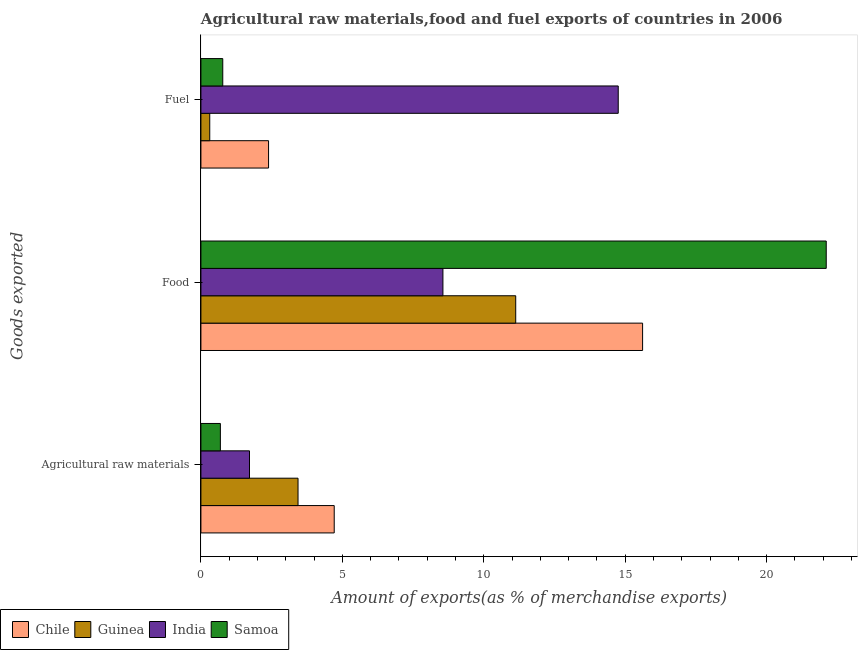How many different coloured bars are there?
Provide a succinct answer. 4. How many groups of bars are there?
Offer a terse response. 3. Are the number of bars on each tick of the Y-axis equal?
Provide a succinct answer. Yes. How many bars are there on the 2nd tick from the top?
Your answer should be very brief. 4. What is the label of the 1st group of bars from the top?
Offer a terse response. Fuel. What is the percentage of raw materials exports in India?
Make the answer very short. 1.72. Across all countries, what is the maximum percentage of food exports?
Provide a short and direct response. 22.11. Across all countries, what is the minimum percentage of fuel exports?
Offer a very short reply. 0.31. In which country was the percentage of food exports maximum?
Provide a succinct answer. Samoa. In which country was the percentage of fuel exports minimum?
Keep it short and to the point. Guinea. What is the total percentage of fuel exports in the graph?
Make the answer very short. 18.23. What is the difference between the percentage of fuel exports in Guinea and that in Samoa?
Provide a short and direct response. -0.46. What is the difference between the percentage of food exports in Samoa and the percentage of raw materials exports in Chile?
Provide a short and direct response. 17.39. What is the average percentage of raw materials exports per country?
Give a very brief answer. 2.64. What is the difference between the percentage of fuel exports and percentage of food exports in India?
Provide a succinct answer. 6.2. In how many countries, is the percentage of fuel exports greater than 17 %?
Offer a terse response. 0. What is the ratio of the percentage of fuel exports in Guinea to that in Samoa?
Make the answer very short. 0.4. Is the percentage of food exports in Chile less than that in Samoa?
Provide a short and direct response. Yes. Is the difference between the percentage of food exports in Guinea and India greater than the difference between the percentage of fuel exports in Guinea and India?
Your answer should be compact. Yes. What is the difference between the highest and the second highest percentage of food exports?
Provide a succinct answer. 6.49. What is the difference between the highest and the lowest percentage of fuel exports?
Provide a short and direct response. 14.44. In how many countries, is the percentage of raw materials exports greater than the average percentage of raw materials exports taken over all countries?
Offer a very short reply. 2. Is the sum of the percentage of raw materials exports in India and Guinea greater than the maximum percentage of food exports across all countries?
Keep it short and to the point. No. What does the 1st bar from the top in Food represents?
Your answer should be very brief. Samoa. What does the 3rd bar from the bottom in Agricultural raw materials represents?
Keep it short and to the point. India. Is it the case that in every country, the sum of the percentage of raw materials exports and percentage of food exports is greater than the percentage of fuel exports?
Your answer should be very brief. No. How many countries are there in the graph?
Ensure brevity in your answer.  4. What is the difference between two consecutive major ticks on the X-axis?
Offer a terse response. 5. Are the values on the major ticks of X-axis written in scientific E-notation?
Provide a succinct answer. No. Where does the legend appear in the graph?
Offer a very short reply. Bottom left. What is the title of the graph?
Your answer should be compact. Agricultural raw materials,food and fuel exports of countries in 2006. What is the label or title of the X-axis?
Ensure brevity in your answer.  Amount of exports(as % of merchandise exports). What is the label or title of the Y-axis?
Provide a succinct answer. Goods exported. What is the Amount of exports(as % of merchandise exports) of Chile in Agricultural raw materials?
Your answer should be very brief. 4.71. What is the Amount of exports(as % of merchandise exports) in Guinea in Agricultural raw materials?
Provide a short and direct response. 3.43. What is the Amount of exports(as % of merchandise exports) in India in Agricultural raw materials?
Provide a succinct answer. 1.72. What is the Amount of exports(as % of merchandise exports) of Samoa in Agricultural raw materials?
Offer a very short reply. 0.69. What is the Amount of exports(as % of merchandise exports) in Chile in Food?
Your response must be concise. 15.62. What is the Amount of exports(as % of merchandise exports) of Guinea in Food?
Provide a succinct answer. 11.13. What is the Amount of exports(as % of merchandise exports) in India in Food?
Keep it short and to the point. 8.56. What is the Amount of exports(as % of merchandise exports) of Samoa in Food?
Your answer should be very brief. 22.11. What is the Amount of exports(as % of merchandise exports) in Chile in Fuel?
Ensure brevity in your answer.  2.39. What is the Amount of exports(as % of merchandise exports) in Guinea in Fuel?
Provide a short and direct response. 0.31. What is the Amount of exports(as % of merchandise exports) in India in Fuel?
Your response must be concise. 14.75. What is the Amount of exports(as % of merchandise exports) in Samoa in Fuel?
Your answer should be very brief. 0.77. Across all Goods exported, what is the maximum Amount of exports(as % of merchandise exports) in Chile?
Provide a short and direct response. 15.62. Across all Goods exported, what is the maximum Amount of exports(as % of merchandise exports) of Guinea?
Offer a very short reply. 11.13. Across all Goods exported, what is the maximum Amount of exports(as % of merchandise exports) of India?
Offer a terse response. 14.75. Across all Goods exported, what is the maximum Amount of exports(as % of merchandise exports) in Samoa?
Keep it short and to the point. 22.11. Across all Goods exported, what is the minimum Amount of exports(as % of merchandise exports) of Chile?
Keep it short and to the point. 2.39. Across all Goods exported, what is the minimum Amount of exports(as % of merchandise exports) of Guinea?
Offer a very short reply. 0.31. Across all Goods exported, what is the minimum Amount of exports(as % of merchandise exports) in India?
Your answer should be very brief. 1.72. Across all Goods exported, what is the minimum Amount of exports(as % of merchandise exports) of Samoa?
Give a very brief answer. 0.69. What is the total Amount of exports(as % of merchandise exports) of Chile in the graph?
Your response must be concise. 22.72. What is the total Amount of exports(as % of merchandise exports) of Guinea in the graph?
Your answer should be very brief. 14.88. What is the total Amount of exports(as % of merchandise exports) of India in the graph?
Your answer should be compact. 25.03. What is the total Amount of exports(as % of merchandise exports) of Samoa in the graph?
Your answer should be compact. 23.57. What is the difference between the Amount of exports(as % of merchandise exports) of Chile in Agricultural raw materials and that in Food?
Make the answer very short. -10.9. What is the difference between the Amount of exports(as % of merchandise exports) of Guinea in Agricultural raw materials and that in Food?
Your response must be concise. -7.7. What is the difference between the Amount of exports(as % of merchandise exports) in India in Agricultural raw materials and that in Food?
Give a very brief answer. -6.84. What is the difference between the Amount of exports(as % of merchandise exports) of Samoa in Agricultural raw materials and that in Food?
Ensure brevity in your answer.  -21.42. What is the difference between the Amount of exports(as % of merchandise exports) of Chile in Agricultural raw materials and that in Fuel?
Your answer should be compact. 2.32. What is the difference between the Amount of exports(as % of merchandise exports) of Guinea in Agricultural raw materials and that in Fuel?
Your answer should be compact. 3.12. What is the difference between the Amount of exports(as % of merchandise exports) of India in Agricultural raw materials and that in Fuel?
Keep it short and to the point. -13.04. What is the difference between the Amount of exports(as % of merchandise exports) of Samoa in Agricultural raw materials and that in Fuel?
Provide a short and direct response. -0.08. What is the difference between the Amount of exports(as % of merchandise exports) in Chile in Food and that in Fuel?
Your answer should be compact. 13.22. What is the difference between the Amount of exports(as % of merchandise exports) of Guinea in Food and that in Fuel?
Your answer should be very brief. 10.82. What is the difference between the Amount of exports(as % of merchandise exports) in India in Food and that in Fuel?
Provide a succinct answer. -6.2. What is the difference between the Amount of exports(as % of merchandise exports) of Samoa in Food and that in Fuel?
Provide a short and direct response. 21.34. What is the difference between the Amount of exports(as % of merchandise exports) in Chile in Agricultural raw materials and the Amount of exports(as % of merchandise exports) in Guinea in Food?
Provide a succinct answer. -6.42. What is the difference between the Amount of exports(as % of merchandise exports) in Chile in Agricultural raw materials and the Amount of exports(as % of merchandise exports) in India in Food?
Ensure brevity in your answer.  -3.84. What is the difference between the Amount of exports(as % of merchandise exports) in Chile in Agricultural raw materials and the Amount of exports(as % of merchandise exports) in Samoa in Food?
Your answer should be compact. -17.39. What is the difference between the Amount of exports(as % of merchandise exports) in Guinea in Agricultural raw materials and the Amount of exports(as % of merchandise exports) in India in Food?
Your response must be concise. -5.12. What is the difference between the Amount of exports(as % of merchandise exports) in Guinea in Agricultural raw materials and the Amount of exports(as % of merchandise exports) in Samoa in Food?
Make the answer very short. -18.67. What is the difference between the Amount of exports(as % of merchandise exports) in India in Agricultural raw materials and the Amount of exports(as % of merchandise exports) in Samoa in Food?
Make the answer very short. -20.39. What is the difference between the Amount of exports(as % of merchandise exports) in Chile in Agricultural raw materials and the Amount of exports(as % of merchandise exports) in Guinea in Fuel?
Provide a succinct answer. 4.4. What is the difference between the Amount of exports(as % of merchandise exports) in Chile in Agricultural raw materials and the Amount of exports(as % of merchandise exports) in India in Fuel?
Keep it short and to the point. -10.04. What is the difference between the Amount of exports(as % of merchandise exports) in Chile in Agricultural raw materials and the Amount of exports(as % of merchandise exports) in Samoa in Fuel?
Make the answer very short. 3.94. What is the difference between the Amount of exports(as % of merchandise exports) in Guinea in Agricultural raw materials and the Amount of exports(as % of merchandise exports) in India in Fuel?
Your answer should be compact. -11.32. What is the difference between the Amount of exports(as % of merchandise exports) in Guinea in Agricultural raw materials and the Amount of exports(as % of merchandise exports) in Samoa in Fuel?
Provide a succinct answer. 2.66. What is the difference between the Amount of exports(as % of merchandise exports) of India in Agricultural raw materials and the Amount of exports(as % of merchandise exports) of Samoa in Fuel?
Ensure brevity in your answer.  0.95. What is the difference between the Amount of exports(as % of merchandise exports) in Chile in Food and the Amount of exports(as % of merchandise exports) in Guinea in Fuel?
Your answer should be very brief. 15.3. What is the difference between the Amount of exports(as % of merchandise exports) of Chile in Food and the Amount of exports(as % of merchandise exports) of India in Fuel?
Your answer should be very brief. 0.86. What is the difference between the Amount of exports(as % of merchandise exports) of Chile in Food and the Amount of exports(as % of merchandise exports) of Samoa in Fuel?
Offer a terse response. 14.84. What is the difference between the Amount of exports(as % of merchandise exports) in Guinea in Food and the Amount of exports(as % of merchandise exports) in India in Fuel?
Provide a succinct answer. -3.62. What is the difference between the Amount of exports(as % of merchandise exports) in Guinea in Food and the Amount of exports(as % of merchandise exports) in Samoa in Fuel?
Provide a short and direct response. 10.36. What is the difference between the Amount of exports(as % of merchandise exports) of India in Food and the Amount of exports(as % of merchandise exports) of Samoa in Fuel?
Provide a succinct answer. 7.78. What is the average Amount of exports(as % of merchandise exports) in Chile per Goods exported?
Keep it short and to the point. 7.57. What is the average Amount of exports(as % of merchandise exports) in Guinea per Goods exported?
Your response must be concise. 4.96. What is the average Amount of exports(as % of merchandise exports) of India per Goods exported?
Give a very brief answer. 8.34. What is the average Amount of exports(as % of merchandise exports) of Samoa per Goods exported?
Give a very brief answer. 7.86. What is the difference between the Amount of exports(as % of merchandise exports) of Chile and Amount of exports(as % of merchandise exports) of Guinea in Agricultural raw materials?
Your answer should be very brief. 1.28. What is the difference between the Amount of exports(as % of merchandise exports) in Chile and Amount of exports(as % of merchandise exports) in India in Agricultural raw materials?
Provide a short and direct response. 3. What is the difference between the Amount of exports(as % of merchandise exports) in Chile and Amount of exports(as % of merchandise exports) in Samoa in Agricultural raw materials?
Provide a short and direct response. 4.02. What is the difference between the Amount of exports(as % of merchandise exports) of Guinea and Amount of exports(as % of merchandise exports) of India in Agricultural raw materials?
Offer a terse response. 1.72. What is the difference between the Amount of exports(as % of merchandise exports) of Guinea and Amount of exports(as % of merchandise exports) of Samoa in Agricultural raw materials?
Make the answer very short. 2.75. What is the difference between the Amount of exports(as % of merchandise exports) of India and Amount of exports(as % of merchandise exports) of Samoa in Agricultural raw materials?
Offer a terse response. 1.03. What is the difference between the Amount of exports(as % of merchandise exports) in Chile and Amount of exports(as % of merchandise exports) in Guinea in Food?
Your response must be concise. 4.49. What is the difference between the Amount of exports(as % of merchandise exports) in Chile and Amount of exports(as % of merchandise exports) in India in Food?
Provide a short and direct response. 7.06. What is the difference between the Amount of exports(as % of merchandise exports) of Chile and Amount of exports(as % of merchandise exports) of Samoa in Food?
Offer a terse response. -6.49. What is the difference between the Amount of exports(as % of merchandise exports) of Guinea and Amount of exports(as % of merchandise exports) of India in Food?
Your answer should be very brief. 2.57. What is the difference between the Amount of exports(as % of merchandise exports) of Guinea and Amount of exports(as % of merchandise exports) of Samoa in Food?
Give a very brief answer. -10.98. What is the difference between the Amount of exports(as % of merchandise exports) of India and Amount of exports(as % of merchandise exports) of Samoa in Food?
Your response must be concise. -13.55. What is the difference between the Amount of exports(as % of merchandise exports) in Chile and Amount of exports(as % of merchandise exports) in Guinea in Fuel?
Make the answer very short. 2.08. What is the difference between the Amount of exports(as % of merchandise exports) of Chile and Amount of exports(as % of merchandise exports) of India in Fuel?
Offer a terse response. -12.36. What is the difference between the Amount of exports(as % of merchandise exports) in Chile and Amount of exports(as % of merchandise exports) in Samoa in Fuel?
Ensure brevity in your answer.  1.62. What is the difference between the Amount of exports(as % of merchandise exports) in Guinea and Amount of exports(as % of merchandise exports) in India in Fuel?
Keep it short and to the point. -14.44. What is the difference between the Amount of exports(as % of merchandise exports) of Guinea and Amount of exports(as % of merchandise exports) of Samoa in Fuel?
Your response must be concise. -0.46. What is the difference between the Amount of exports(as % of merchandise exports) of India and Amount of exports(as % of merchandise exports) of Samoa in Fuel?
Offer a terse response. 13.98. What is the ratio of the Amount of exports(as % of merchandise exports) of Chile in Agricultural raw materials to that in Food?
Your response must be concise. 0.3. What is the ratio of the Amount of exports(as % of merchandise exports) in Guinea in Agricultural raw materials to that in Food?
Your answer should be very brief. 0.31. What is the ratio of the Amount of exports(as % of merchandise exports) of India in Agricultural raw materials to that in Food?
Give a very brief answer. 0.2. What is the ratio of the Amount of exports(as % of merchandise exports) in Samoa in Agricultural raw materials to that in Food?
Make the answer very short. 0.03. What is the ratio of the Amount of exports(as % of merchandise exports) in Chile in Agricultural raw materials to that in Fuel?
Make the answer very short. 1.97. What is the ratio of the Amount of exports(as % of merchandise exports) in Guinea in Agricultural raw materials to that in Fuel?
Ensure brevity in your answer.  11. What is the ratio of the Amount of exports(as % of merchandise exports) of India in Agricultural raw materials to that in Fuel?
Offer a terse response. 0.12. What is the ratio of the Amount of exports(as % of merchandise exports) of Samoa in Agricultural raw materials to that in Fuel?
Your answer should be very brief. 0.89. What is the ratio of the Amount of exports(as % of merchandise exports) of Chile in Food to that in Fuel?
Offer a very short reply. 6.53. What is the ratio of the Amount of exports(as % of merchandise exports) of Guinea in Food to that in Fuel?
Your answer should be very brief. 35.65. What is the ratio of the Amount of exports(as % of merchandise exports) of India in Food to that in Fuel?
Your response must be concise. 0.58. What is the ratio of the Amount of exports(as % of merchandise exports) of Samoa in Food to that in Fuel?
Provide a succinct answer. 28.63. What is the difference between the highest and the second highest Amount of exports(as % of merchandise exports) of Chile?
Provide a succinct answer. 10.9. What is the difference between the highest and the second highest Amount of exports(as % of merchandise exports) in Guinea?
Your answer should be compact. 7.7. What is the difference between the highest and the second highest Amount of exports(as % of merchandise exports) of India?
Keep it short and to the point. 6.2. What is the difference between the highest and the second highest Amount of exports(as % of merchandise exports) in Samoa?
Make the answer very short. 21.34. What is the difference between the highest and the lowest Amount of exports(as % of merchandise exports) of Chile?
Give a very brief answer. 13.22. What is the difference between the highest and the lowest Amount of exports(as % of merchandise exports) of Guinea?
Provide a succinct answer. 10.82. What is the difference between the highest and the lowest Amount of exports(as % of merchandise exports) of India?
Provide a succinct answer. 13.04. What is the difference between the highest and the lowest Amount of exports(as % of merchandise exports) of Samoa?
Provide a short and direct response. 21.42. 